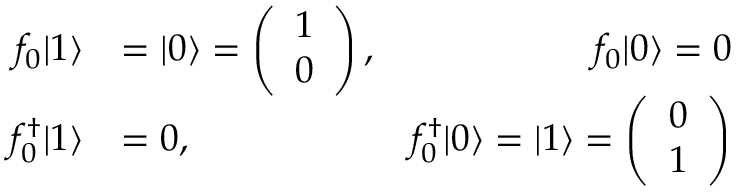<formula> <loc_0><loc_0><loc_500><loc_500>\begin{array} { r l r } { f _ { 0 } | 1 \rangle } & { = | 0 \rangle = \left ( \begin{array} { l } { 1 } \\ { 0 } \end{array} \right ) , } & { f _ { 0 } | 0 \rangle = 0 } \\ { f _ { 0 } ^ { \dagger } | 1 \rangle } & { = 0 , } & { f _ { 0 } ^ { \dagger } | 0 \rangle = | 1 \rangle = \left ( \begin{array} { l l } { 0 } \\ { 1 } \end{array} \right ) } \end{array}</formula> 